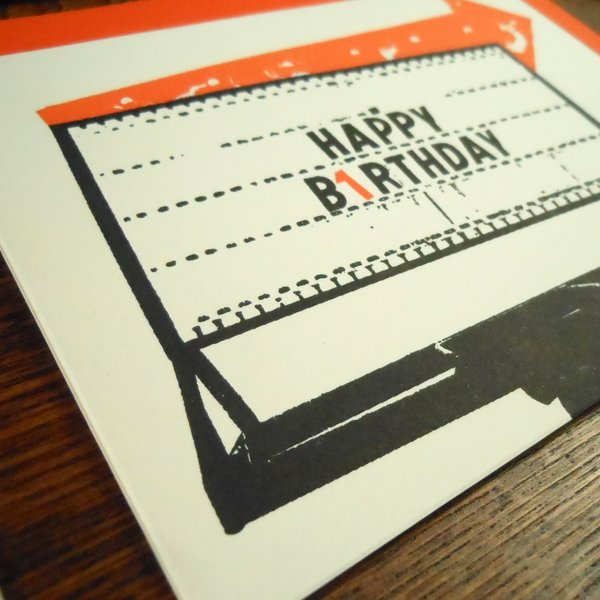What other visual elements contribute to the vintage feel of this card? Besides the smudge effect on the text, several other elements contribute to the card's vintage feel. The font choice resembles typewriter typography, with its monospaced, slightly irregular characters. The color palette, featuring faded black and orange tones, evokes the look of aged prints and oxidized inks. The overall layout mimics a typewriter page, complete with spacing that suggests a mechanical alignment. The background has a subtle, worn texture that gives the impression of aged, slightly yellowed paper. All these details work together to enhance the retro aesthetic, making the card a nostalgic nod to the past. Do you think the recipient would appreciate the retro design? Why or why not? The recipient would likely appreciate the retro design if they have an affinity for vintage items or a love for nostalgia. The tactile and visual qualities of the card, reminiscent of a typewriter's output, can evoke fond memories and a sense of nostalgia. The imperfections, such as the smudged ink, add character and charm, making the card not just a greeting but a piece of art that celebrates the past. Additionally, retro designs often stand out in a digital age where sleek, minimal aesthetics dominate, making this card a unique and thoughtful gesture. However, if the recipient prefers modern or sleek designs, they might not fully appreciate the vintage elements. 